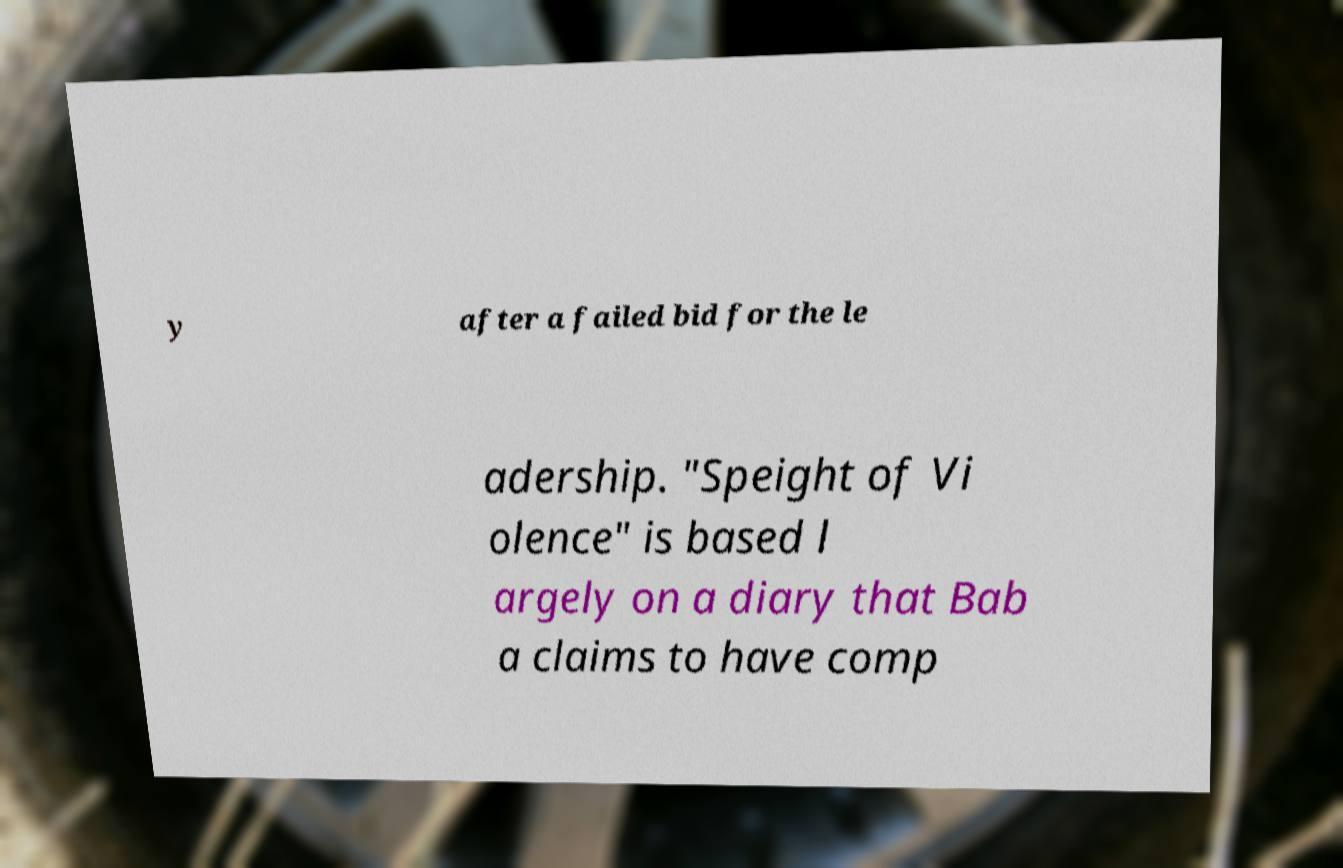Please identify and transcribe the text found in this image. y after a failed bid for the le adership. "Speight of Vi olence" is based l argely on a diary that Bab a claims to have comp 